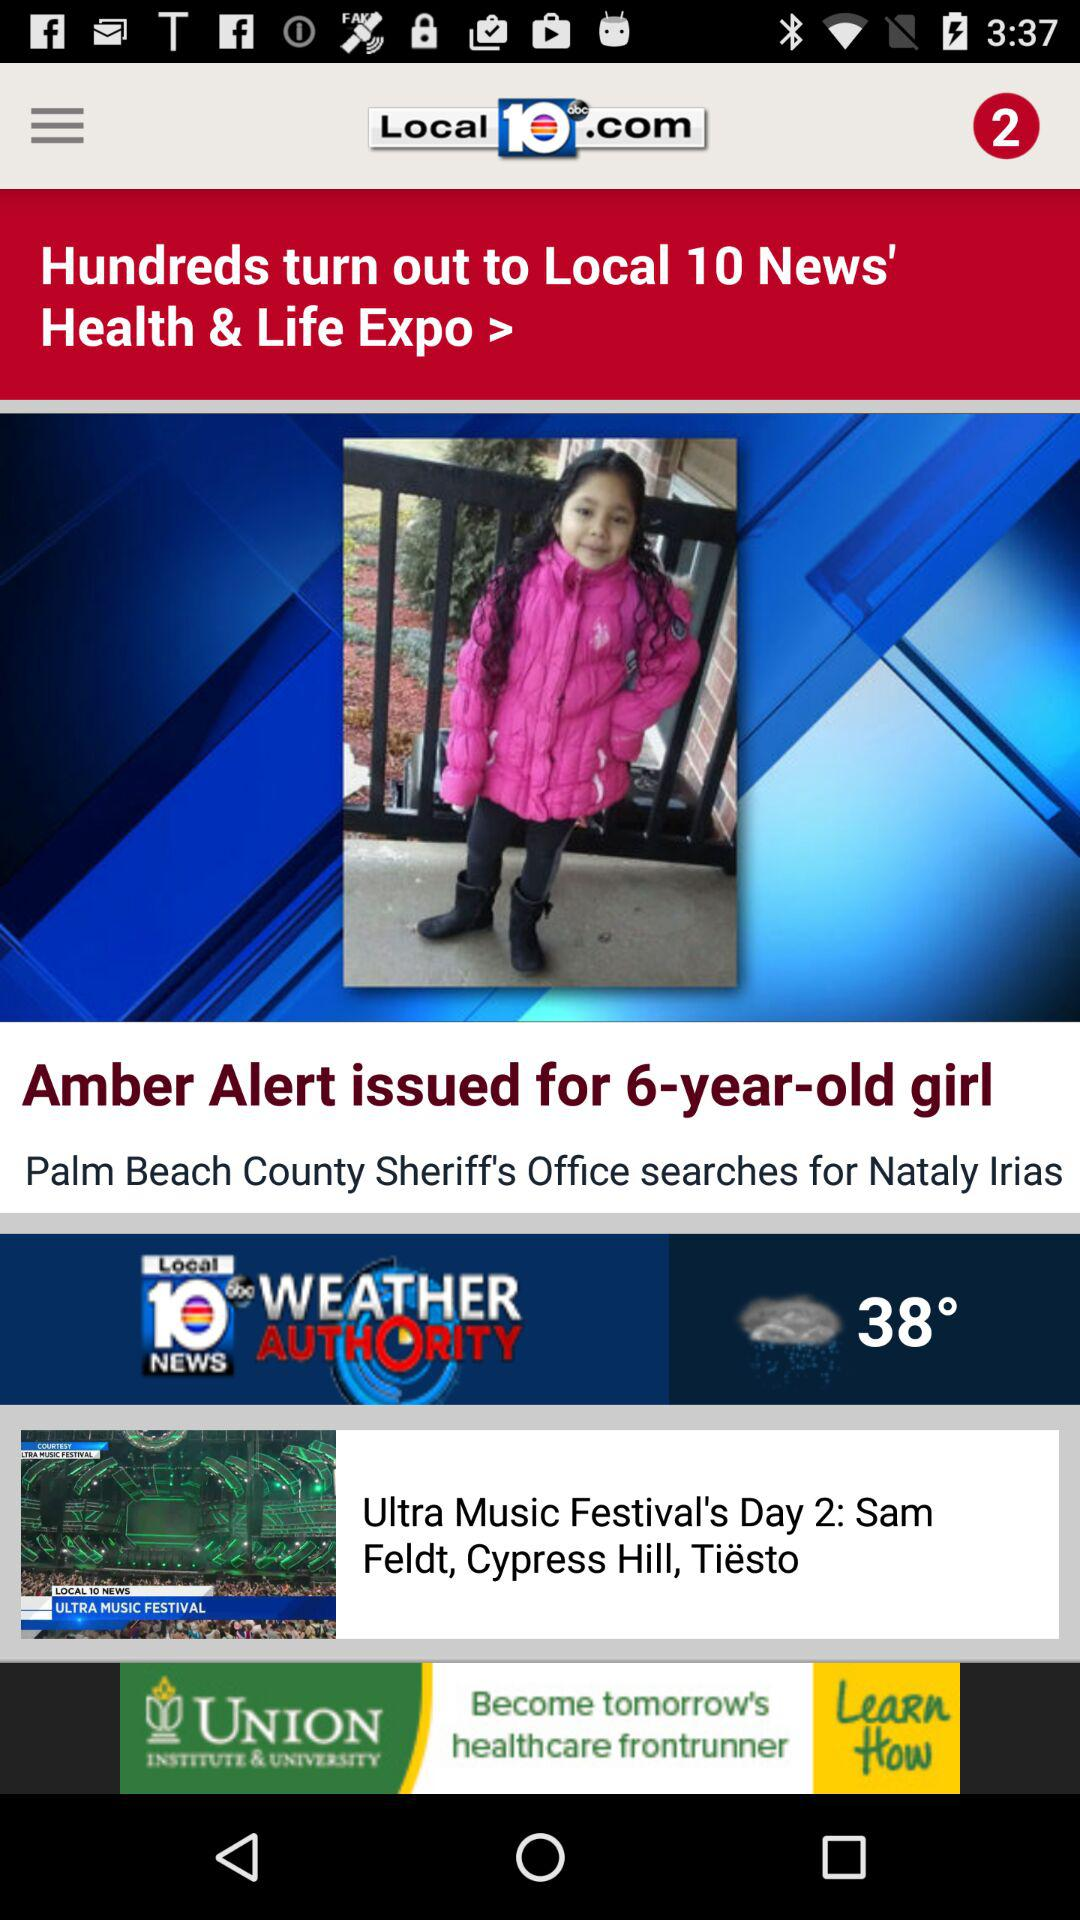What is the number of new notifications?
When the provided information is insufficient, respond with <no answer>. <no answer> 